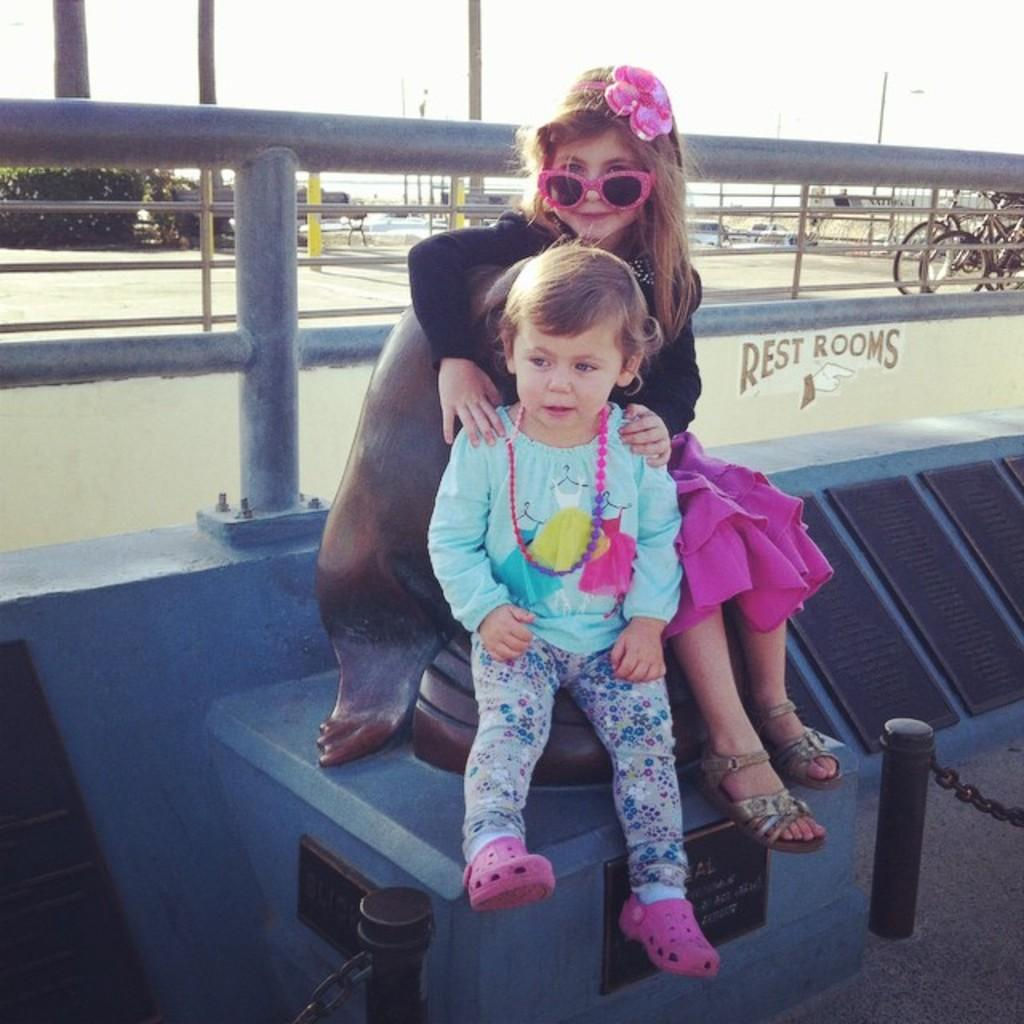How many children are sitting in the image? There are two children sitting in the image. What can be seen in the background of the image? There is a fence visible in the image. What objects are present that are typically used for transportation? There are bicycles in the image. What type of vertical structures can be seen in the image? There are poles in the image. What type of vegetation is present in the image? There are plants in the image. What is the condition of the sky in the image? The sky is visible in the image and appears cloudy. What type of slave is depicted in the image? There is no depiction of a slave in the image. 